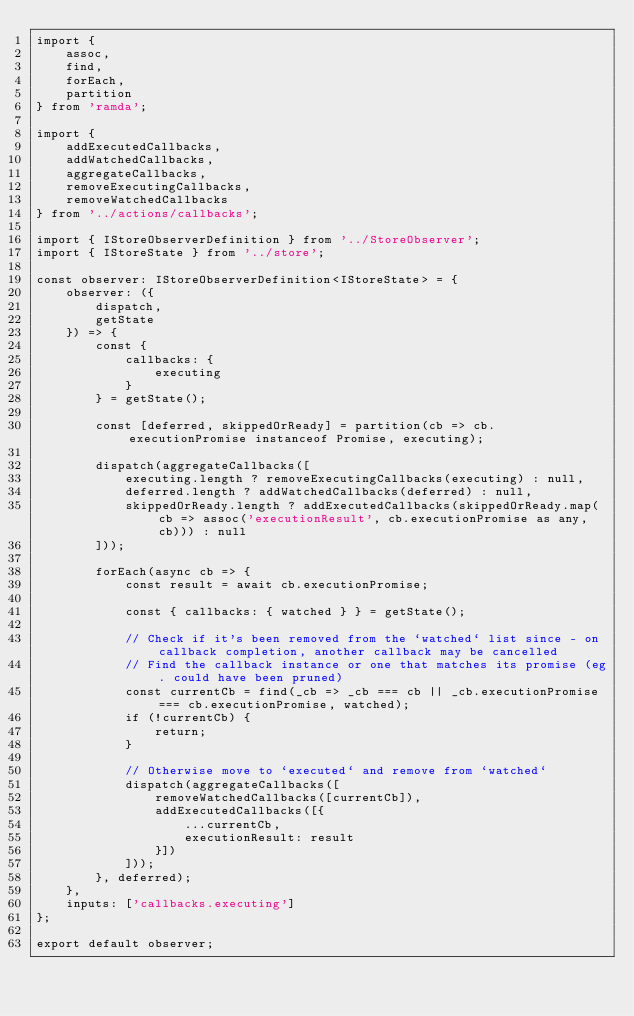<code> <loc_0><loc_0><loc_500><loc_500><_TypeScript_>import {
    assoc,
    find,
    forEach,
    partition
} from 'ramda';

import {
    addExecutedCallbacks,
    addWatchedCallbacks,
    aggregateCallbacks,
    removeExecutingCallbacks,
    removeWatchedCallbacks
} from '../actions/callbacks';

import { IStoreObserverDefinition } from '../StoreObserver';
import { IStoreState } from '../store';

const observer: IStoreObserverDefinition<IStoreState> = {
    observer: ({
        dispatch,
        getState
    }) => {
        const {
            callbacks: {
                executing
            }
        } = getState();

        const [deferred, skippedOrReady] = partition(cb => cb.executionPromise instanceof Promise, executing);

        dispatch(aggregateCallbacks([
            executing.length ? removeExecutingCallbacks(executing) : null,
            deferred.length ? addWatchedCallbacks(deferred) : null,
            skippedOrReady.length ? addExecutedCallbacks(skippedOrReady.map(cb => assoc('executionResult', cb.executionPromise as any, cb))) : null
        ]));

        forEach(async cb => {
            const result = await cb.executionPromise;

            const { callbacks: { watched } } = getState();

            // Check if it's been removed from the `watched` list since - on callback completion, another callback may be cancelled
            // Find the callback instance or one that matches its promise (eg. could have been pruned)
            const currentCb = find(_cb => _cb === cb || _cb.executionPromise === cb.executionPromise, watched);
            if (!currentCb) {
                return;
            }

            // Otherwise move to `executed` and remove from `watched`
            dispatch(aggregateCallbacks([
                removeWatchedCallbacks([currentCb]),
                addExecutedCallbacks([{
                    ...currentCb,
                    executionResult: result
                }])
            ]));
        }, deferred);
    },
    inputs: ['callbacks.executing']
};

export default observer;
</code> 